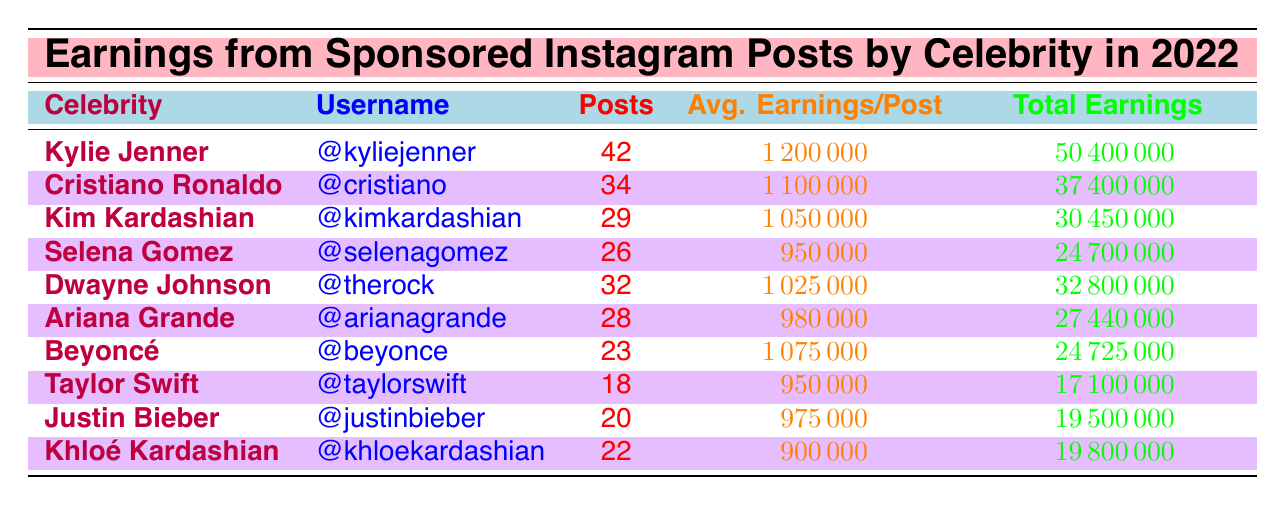What is the total earnings for Kylie Jenner? From the table, under Kylie Jenner's row, the total earnings are listed as 50400000.
Answer: 50400000 How many posts did Cristiano Ronaldo make in 2022? The number of posts for Cristiano Ronaldo is recorded in the table, and it shows 34 posts.
Answer: 34 Who has the highest average earnings per post? By comparing the average earnings per post from all celebrities in the table, it is clear that Kylie Jenner has the highest at 1200000.
Answer: Kylie Jenner Calculate the total earnings of the top three earners (Kylie Jenner, Cristiano Ronaldo, and Kim Kardashian). Adding the total earnings from each of the top three earners: 50400000 (Kylie) + 37400000 (Cristiano) + 30450000 (Kim) = 118450000.
Answer: 118450000 Does Taylor Swift have more posts than Beyoncé? From the data, Taylor Swift has 18 posts and Beyoncé has 23 posts. Therefore, Taylor Swift has fewer posts than Beyoncé.
Answer: No Which celebrity had the least earnings, and what is the total amount? By comparing total earnings in the table, Khloé Kardashian has the least earnings at 19800000.
Answer: Khloé Kardashian, 19800000 If you combine the earnings of Ariana Grande and Selena Gomez, how much would that be? Ariana Grande's earnings are 27440000 and Selena Gomez's are 24700000. Their combined total is 27440000 + 24700000 = 52140000.
Answer: 52140000 Is the average earnings per post for Dwayne Johnson greater than 1 million? Dwayne Johnson's average earnings per post are 1025000, which is greater than 1 million.
Answer: Yes How many celebrities earned more than 25 million in total? By reviewing the total earnings of all celebrities listed, Kylie Jenner, Cristiano Ronaldo, Kim Kardashian, and Dwayne Johnson earned more than 25 million, totaling four celebrities.
Answer: 4 